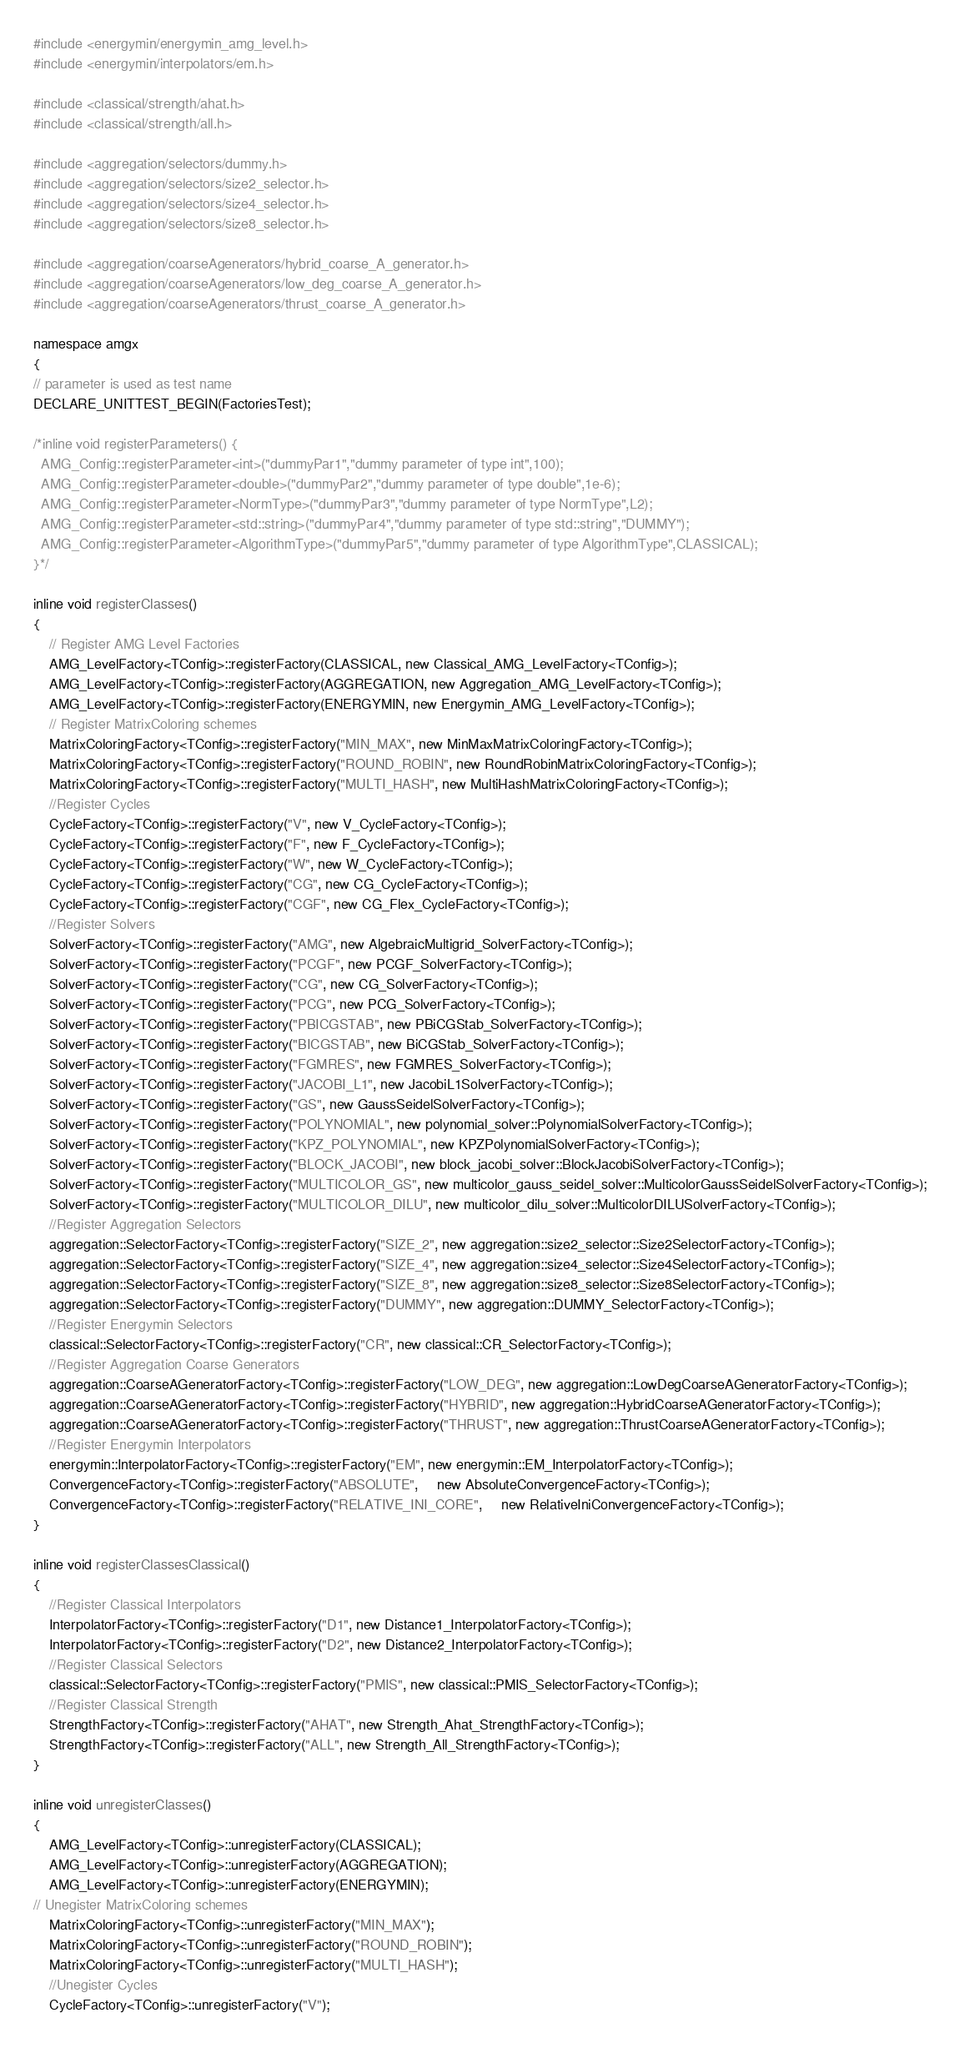Convert code to text. <code><loc_0><loc_0><loc_500><loc_500><_Cuda_>#include <energymin/energymin_amg_level.h>
#include <energymin/interpolators/em.h>

#include <classical/strength/ahat.h>
#include <classical/strength/all.h>

#include <aggregation/selectors/dummy.h>
#include <aggregation/selectors/size2_selector.h>
#include <aggregation/selectors/size4_selector.h>
#include <aggregation/selectors/size8_selector.h>

#include <aggregation/coarseAgenerators/hybrid_coarse_A_generator.h>
#include <aggregation/coarseAgenerators/low_deg_coarse_A_generator.h>
#include <aggregation/coarseAgenerators/thrust_coarse_A_generator.h>

namespace amgx
{
// parameter is used as test name
DECLARE_UNITTEST_BEGIN(FactoriesTest);

/*inline void registerParameters() {
  AMG_Config::registerParameter<int>("dummyPar1","dummy parameter of type int",100);
  AMG_Config::registerParameter<double>("dummyPar2","dummy parameter of type double",1e-6);
  AMG_Config::registerParameter<NormType>("dummyPar3","dummy parameter of type NormType",L2);
  AMG_Config::registerParameter<std::string>("dummyPar4","dummy parameter of type std::string","DUMMY");
  AMG_Config::registerParameter<AlgorithmType>("dummyPar5","dummy parameter of type AlgorithmType",CLASSICAL);
}*/

inline void registerClasses()
{
    // Register AMG Level Factories
    AMG_LevelFactory<TConfig>::registerFactory(CLASSICAL, new Classical_AMG_LevelFactory<TConfig>);
    AMG_LevelFactory<TConfig>::registerFactory(AGGREGATION, new Aggregation_AMG_LevelFactory<TConfig>);
    AMG_LevelFactory<TConfig>::registerFactory(ENERGYMIN, new Energymin_AMG_LevelFactory<TConfig>);
    // Register MatrixColoring schemes
    MatrixColoringFactory<TConfig>::registerFactory("MIN_MAX", new MinMaxMatrixColoringFactory<TConfig>);
    MatrixColoringFactory<TConfig>::registerFactory("ROUND_ROBIN", new RoundRobinMatrixColoringFactory<TConfig>);
    MatrixColoringFactory<TConfig>::registerFactory("MULTI_HASH", new MultiHashMatrixColoringFactory<TConfig>);
    //Register Cycles
    CycleFactory<TConfig>::registerFactory("V", new V_CycleFactory<TConfig>);
    CycleFactory<TConfig>::registerFactory("F", new F_CycleFactory<TConfig>);
    CycleFactory<TConfig>::registerFactory("W", new W_CycleFactory<TConfig>);
    CycleFactory<TConfig>::registerFactory("CG", new CG_CycleFactory<TConfig>);
    CycleFactory<TConfig>::registerFactory("CGF", new CG_Flex_CycleFactory<TConfig>);
    //Register Solvers
    SolverFactory<TConfig>::registerFactory("AMG", new AlgebraicMultigrid_SolverFactory<TConfig>);
    SolverFactory<TConfig>::registerFactory("PCGF", new PCGF_SolverFactory<TConfig>);
    SolverFactory<TConfig>::registerFactory("CG", new CG_SolverFactory<TConfig>);
    SolverFactory<TConfig>::registerFactory("PCG", new PCG_SolverFactory<TConfig>);
    SolverFactory<TConfig>::registerFactory("PBICGSTAB", new PBiCGStab_SolverFactory<TConfig>);
    SolverFactory<TConfig>::registerFactory("BICGSTAB", new BiCGStab_SolverFactory<TConfig>);
    SolverFactory<TConfig>::registerFactory("FGMRES", new FGMRES_SolverFactory<TConfig>);
    SolverFactory<TConfig>::registerFactory("JACOBI_L1", new JacobiL1SolverFactory<TConfig>);
    SolverFactory<TConfig>::registerFactory("GS", new GaussSeidelSolverFactory<TConfig>);
    SolverFactory<TConfig>::registerFactory("POLYNOMIAL", new polynomial_solver::PolynomialSolverFactory<TConfig>);
    SolverFactory<TConfig>::registerFactory("KPZ_POLYNOMIAL", new KPZPolynomialSolverFactory<TConfig>);
    SolverFactory<TConfig>::registerFactory("BLOCK_JACOBI", new block_jacobi_solver::BlockJacobiSolverFactory<TConfig>);
    SolverFactory<TConfig>::registerFactory("MULTICOLOR_GS", new multicolor_gauss_seidel_solver::MulticolorGaussSeidelSolverFactory<TConfig>);
    SolverFactory<TConfig>::registerFactory("MULTICOLOR_DILU", new multicolor_dilu_solver::MulticolorDILUSolverFactory<TConfig>);
    //Register Aggregation Selectors
    aggregation::SelectorFactory<TConfig>::registerFactory("SIZE_2", new aggregation::size2_selector::Size2SelectorFactory<TConfig>);
    aggregation::SelectorFactory<TConfig>::registerFactory("SIZE_4", new aggregation::size4_selector::Size4SelectorFactory<TConfig>);
    aggregation::SelectorFactory<TConfig>::registerFactory("SIZE_8", new aggregation::size8_selector::Size8SelectorFactory<TConfig>);
    aggregation::SelectorFactory<TConfig>::registerFactory("DUMMY", new aggregation::DUMMY_SelectorFactory<TConfig>);
    //Register Energymin Selectors
    classical::SelectorFactory<TConfig>::registerFactory("CR", new classical::CR_SelectorFactory<TConfig>);
    //Register Aggregation Coarse Generators
    aggregation::CoarseAGeneratorFactory<TConfig>::registerFactory("LOW_DEG", new aggregation::LowDegCoarseAGeneratorFactory<TConfig>);
    aggregation::CoarseAGeneratorFactory<TConfig>::registerFactory("HYBRID", new aggregation::HybridCoarseAGeneratorFactory<TConfig>);
    aggregation::CoarseAGeneratorFactory<TConfig>::registerFactory("THRUST", new aggregation::ThrustCoarseAGeneratorFactory<TConfig>);
    //Register Energymin Interpolators
    energymin::InterpolatorFactory<TConfig>::registerFactory("EM", new energymin::EM_InterpolatorFactory<TConfig>);
    ConvergenceFactory<TConfig>::registerFactory("ABSOLUTE",     new AbsoluteConvergenceFactory<TConfig>);
    ConvergenceFactory<TConfig>::registerFactory("RELATIVE_INI_CORE",     new RelativeIniConvergenceFactory<TConfig>);
}

inline void registerClassesClassical()
{
    //Register Classical Interpolators
    InterpolatorFactory<TConfig>::registerFactory("D1", new Distance1_InterpolatorFactory<TConfig>);
    InterpolatorFactory<TConfig>::registerFactory("D2", new Distance2_InterpolatorFactory<TConfig>);
    //Register Classical Selectors
    classical::SelectorFactory<TConfig>::registerFactory("PMIS", new classical::PMIS_SelectorFactory<TConfig>);
    //Register Classical Strength
    StrengthFactory<TConfig>::registerFactory("AHAT", new Strength_Ahat_StrengthFactory<TConfig>);
    StrengthFactory<TConfig>::registerFactory("ALL", new Strength_All_StrengthFactory<TConfig>);
}

inline void unregisterClasses()
{
    AMG_LevelFactory<TConfig>::unregisterFactory(CLASSICAL);
    AMG_LevelFactory<TConfig>::unregisterFactory(AGGREGATION);
    AMG_LevelFactory<TConfig>::unregisterFactory(ENERGYMIN);
// Unegister MatrixColoring schemes
    MatrixColoringFactory<TConfig>::unregisterFactory("MIN_MAX");
    MatrixColoringFactory<TConfig>::unregisterFactory("ROUND_ROBIN");
    MatrixColoringFactory<TConfig>::unregisterFactory("MULTI_HASH");
    //Unegister Cycles
    CycleFactory<TConfig>::unregisterFactory("V");</code> 